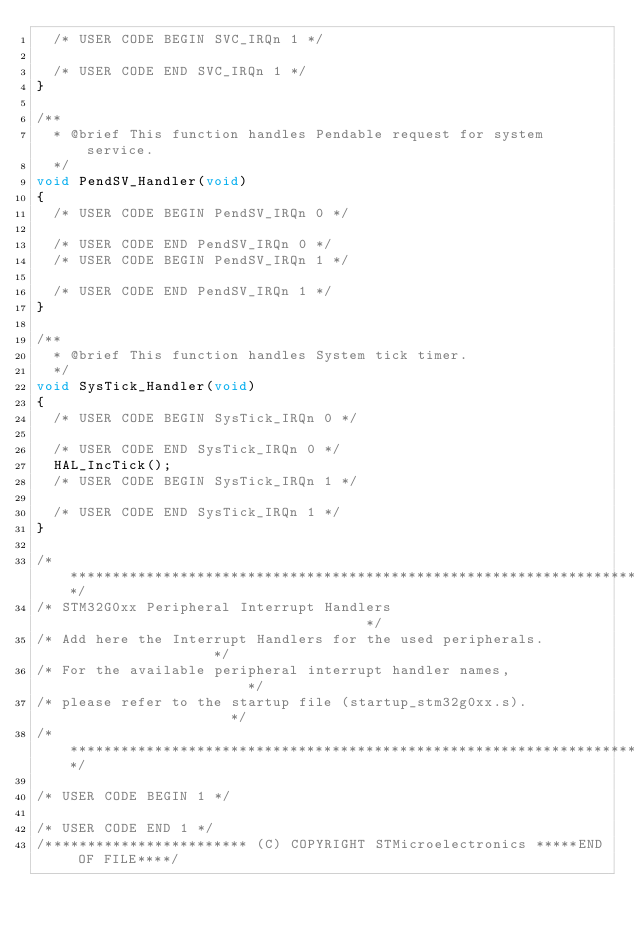<code> <loc_0><loc_0><loc_500><loc_500><_C_>  /* USER CODE BEGIN SVC_IRQn 1 */

  /* USER CODE END SVC_IRQn 1 */
}

/**
  * @brief This function handles Pendable request for system service.
  */
void PendSV_Handler(void)
{
  /* USER CODE BEGIN PendSV_IRQn 0 */

  /* USER CODE END PendSV_IRQn 0 */
  /* USER CODE BEGIN PendSV_IRQn 1 */

  /* USER CODE END PendSV_IRQn 1 */
}

/**
  * @brief This function handles System tick timer.
  */
void SysTick_Handler(void)
{
  /* USER CODE BEGIN SysTick_IRQn 0 */

  /* USER CODE END SysTick_IRQn 0 */
  HAL_IncTick();
  /* USER CODE BEGIN SysTick_IRQn 1 */

  /* USER CODE END SysTick_IRQn 1 */
}

/******************************************************************************/
/* STM32G0xx Peripheral Interrupt Handlers                                    */
/* Add here the Interrupt Handlers for the used peripherals.                  */
/* For the available peripheral interrupt handler names,                      */
/* please refer to the startup file (startup_stm32g0xx.s).                    */
/******************************************************************************/

/* USER CODE BEGIN 1 */

/* USER CODE END 1 */
/************************ (C) COPYRIGHT STMicroelectronics *****END OF FILE****/
</code> 